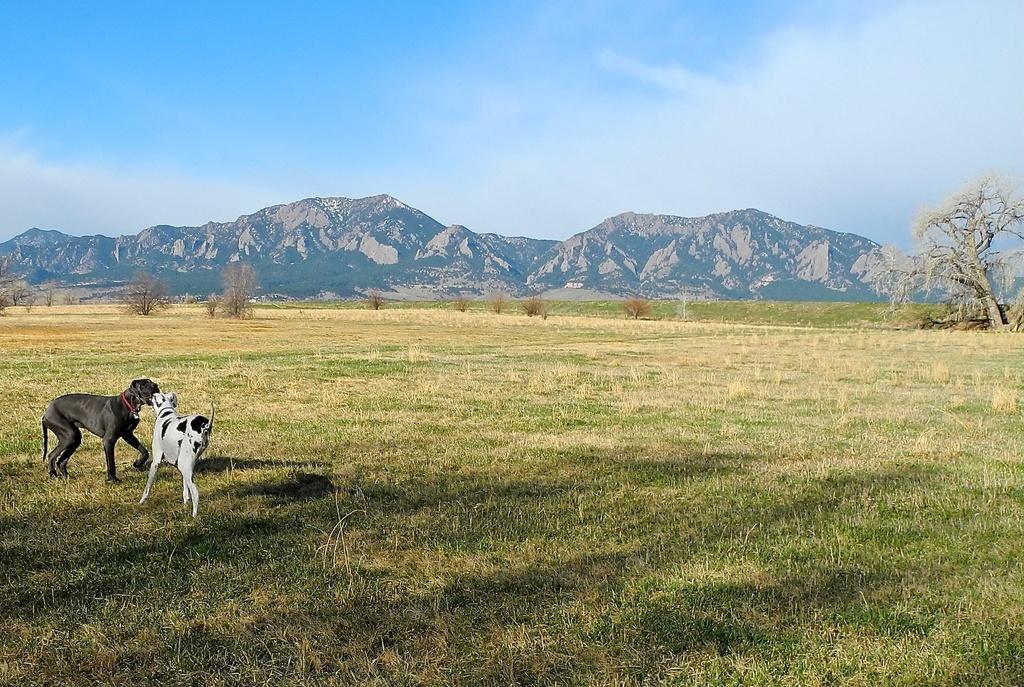Can you describe this image briefly? In this image on the left side there are two dogs, at the bottom there is grass and in the background there are trees and mountains. On the top of the image there is sky. 